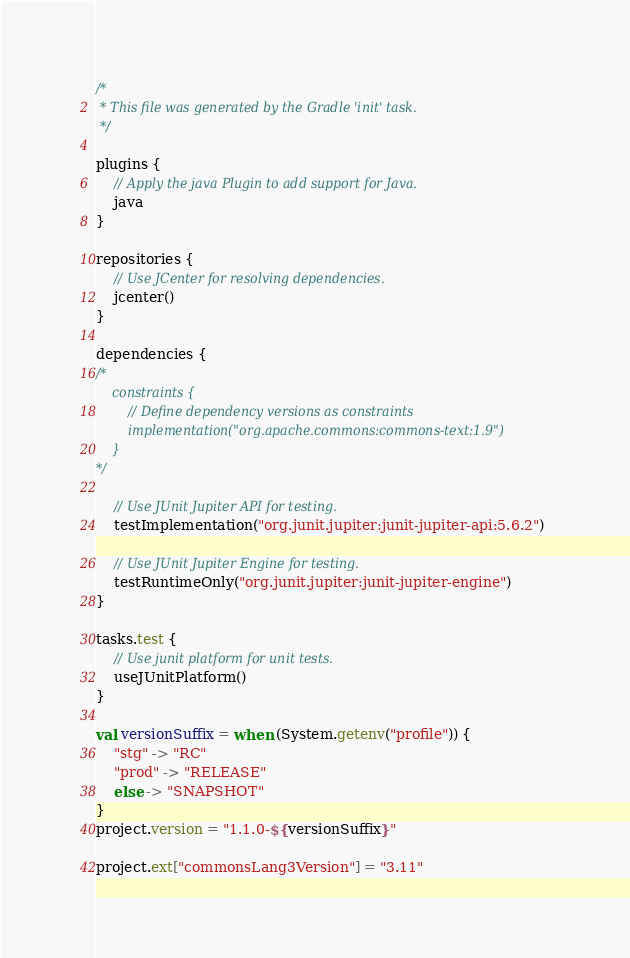Convert code to text. <code><loc_0><loc_0><loc_500><loc_500><_Kotlin_>/*
 * This file was generated by the Gradle 'init' task.
 */

plugins {
    // Apply the java Plugin to add support for Java.
    java
}

repositories {
    // Use JCenter for resolving dependencies.
    jcenter()
}

dependencies {
/*
    constraints {
        // Define dependency versions as constraints
        implementation("org.apache.commons:commons-text:1.9")
    }
*/

    // Use JUnit Jupiter API for testing.
    testImplementation("org.junit.jupiter:junit-jupiter-api:5.6.2")

    // Use JUnit Jupiter Engine for testing.
    testRuntimeOnly("org.junit.jupiter:junit-jupiter-engine")
}

tasks.test {
    // Use junit platform for unit tests.
    useJUnitPlatform()
}

val versionSuffix = when (System.getenv("profile")) {
    "stg" -> "RC"
    "prod" -> "RELEASE"
    else -> "SNAPSHOT"
}
project.version = "1.1.0-${versionSuffix}"

project.ext["commonsLang3Version"] = "3.11"
</code> 